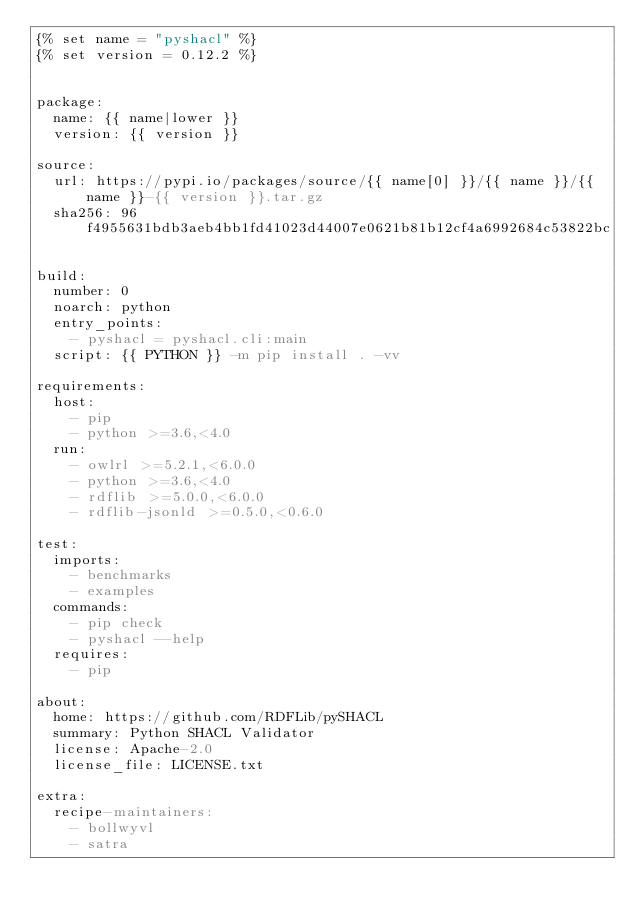<code> <loc_0><loc_0><loc_500><loc_500><_YAML_>{% set name = "pyshacl" %}
{% set version = 0.12.2 %}


package:
  name: {{ name|lower }}
  version: {{ version }}

source:
  url: https://pypi.io/packages/source/{{ name[0] }}/{{ name }}/{{ name }}-{{ version }}.tar.gz
  sha256: 96f4955631bdb3aeb4bb1fd41023d44007e0621b81b12cf4a6992684c53822bc

build:
  number: 0
  noarch: python
  entry_points:
    - pyshacl = pyshacl.cli:main
  script: {{ PYTHON }} -m pip install . -vv

requirements:
  host:
    - pip
    - python >=3.6,<4.0
  run:
    - owlrl >=5.2.1,<6.0.0
    - python >=3.6,<4.0
    - rdflib >=5.0.0,<6.0.0
    - rdflib-jsonld >=0.5.0,<0.6.0

test:
  imports:
    - benchmarks
    - examples
  commands:
    - pip check
    - pyshacl --help
  requires:
    - pip

about:
  home: https://github.com/RDFLib/pySHACL
  summary: Python SHACL Validator
  license: Apache-2.0
  license_file: LICENSE.txt

extra:
  recipe-maintainers:
    - bollwyvl
    - satra
</code> 